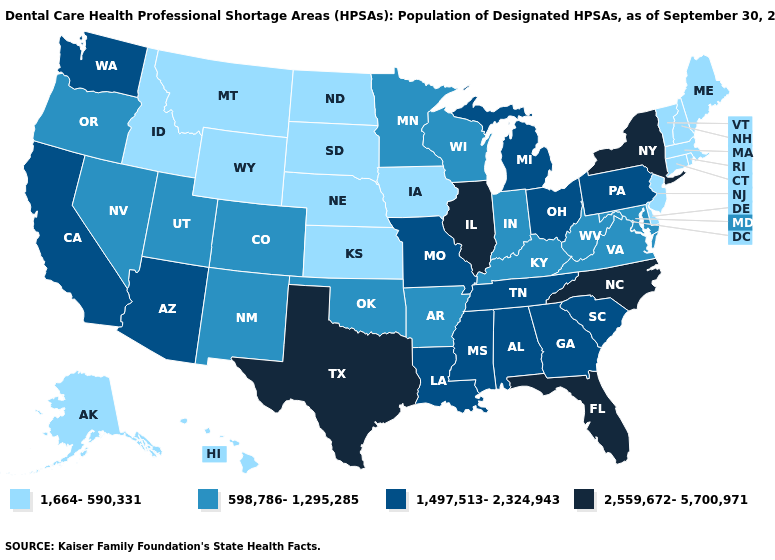What is the value of Oregon?
Concise answer only. 598,786-1,295,285. What is the lowest value in the West?
Write a very short answer. 1,664-590,331. Does Pennsylvania have the lowest value in the Northeast?
Quick response, please. No. What is the highest value in states that border Illinois?
Keep it brief. 1,497,513-2,324,943. Name the states that have a value in the range 2,559,672-5,700,971?
Concise answer only. Florida, Illinois, New York, North Carolina, Texas. Name the states that have a value in the range 1,497,513-2,324,943?
Be succinct. Alabama, Arizona, California, Georgia, Louisiana, Michigan, Mississippi, Missouri, Ohio, Pennsylvania, South Carolina, Tennessee, Washington. Does Texas have the highest value in the South?
Give a very brief answer. Yes. Name the states that have a value in the range 598,786-1,295,285?
Keep it brief. Arkansas, Colorado, Indiana, Kentucky, Maryland, Minnesota, Nevada, New Mexico, Oklahoma, Oregon, Utah, Virginia, West Virginia, Wisconsin. Name the states that have a value in the range 1,664-590,331?
Write a very short answer. Alaska, Connecticut, Delaware, Hawaii, Idaho, Iowa, Kansas, Maine, Massachusetts, Montana, Nebraska, New Hampshire, New Jersey, North Dakota, Rhode Island, South Dakota, Vermont, Wyoming. Does the first symbol in the legend represent the smallest category?
Quick response, please. Yes. Name the states that have a value in the range 1,497,513-2,324,943?
Quick response, please. Alabama, Arizona, California, Georgia, Louisiana, Michigan, Mississippi, Missouri, Ohio, Pennsylvania, South Carolina, Tennessee, Washington. Does Michigan have a higher value than Texas?
Write a very short answer. No. Which states hav the highest value in the Northeast?
Quick response, please. New York. Name the states that have a value in the range 598,786-1,295,285?
Write a very short answer. Arkansas, Colorado, Indiana, Kentucky, Maryland, Minnesota, Nevada, New Mexico, Oklahoma, Oregon, Utah, Virginia, West Virginia, Wisconsin. Name the states that have a value in the range 2,559,672-5,700,971?
Keep it brief. Florida, Illinois, New York, North Carolina, Texas. 